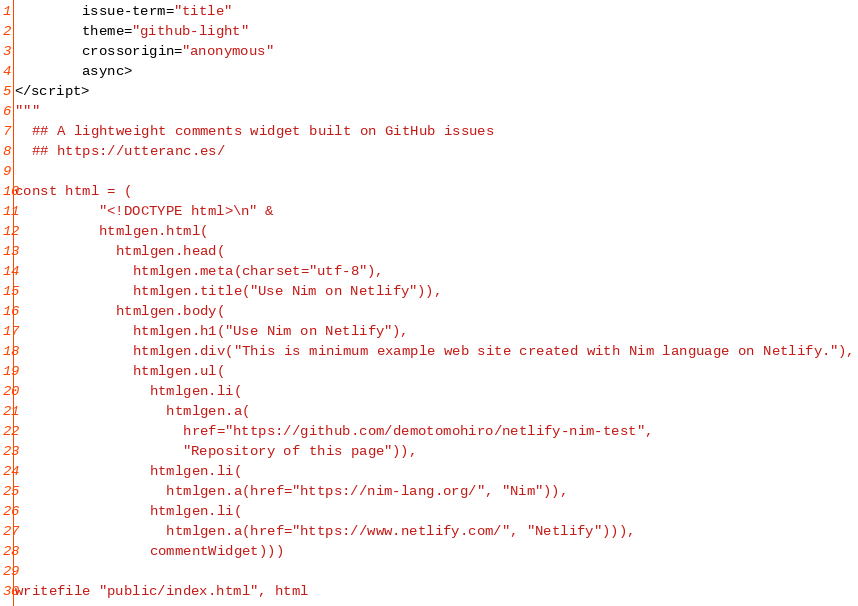Convert code to text. <code><loc_0><loc_0><loc_500><loc_500><_Nim_>        issue-term="title"
        theme="github-light"
        crossorigin="anonymous"
        async>
</script>
"""
  ## A lightweight comments widget built on GitHub issues
  ## https://utteranc.es/

const html = (
          "<!DOCTYPE html>\n" &
          htmlgen.html(
            htmlgen.head(
              htmlgen.meta(charset="utf-8"),
              htmlgen.title("Use Nim on Netlify")),
            htmlgen.body(
              htmlgen.h1("Use Nim on Netlify"),
              htmlgen.div("This is minimum example web site created with Nim language on Netlify."),
              htmlgen.ul(
                htmlgen.li(
                  htmlgen.a(
                    href="https://github.com/demotomohiro/netlify-nim-test",
                    "Repository of this page")),
                htmlgen.li(
                  htmlgen.a(href="https://nim-lang.org/", "Nim")),
                htmlgen.li(
                  htmlgen.a(href="https://www.netlify.com/", "Netlify"))),
                commentWidget)))

writefile "public/index.html", html
</code> 